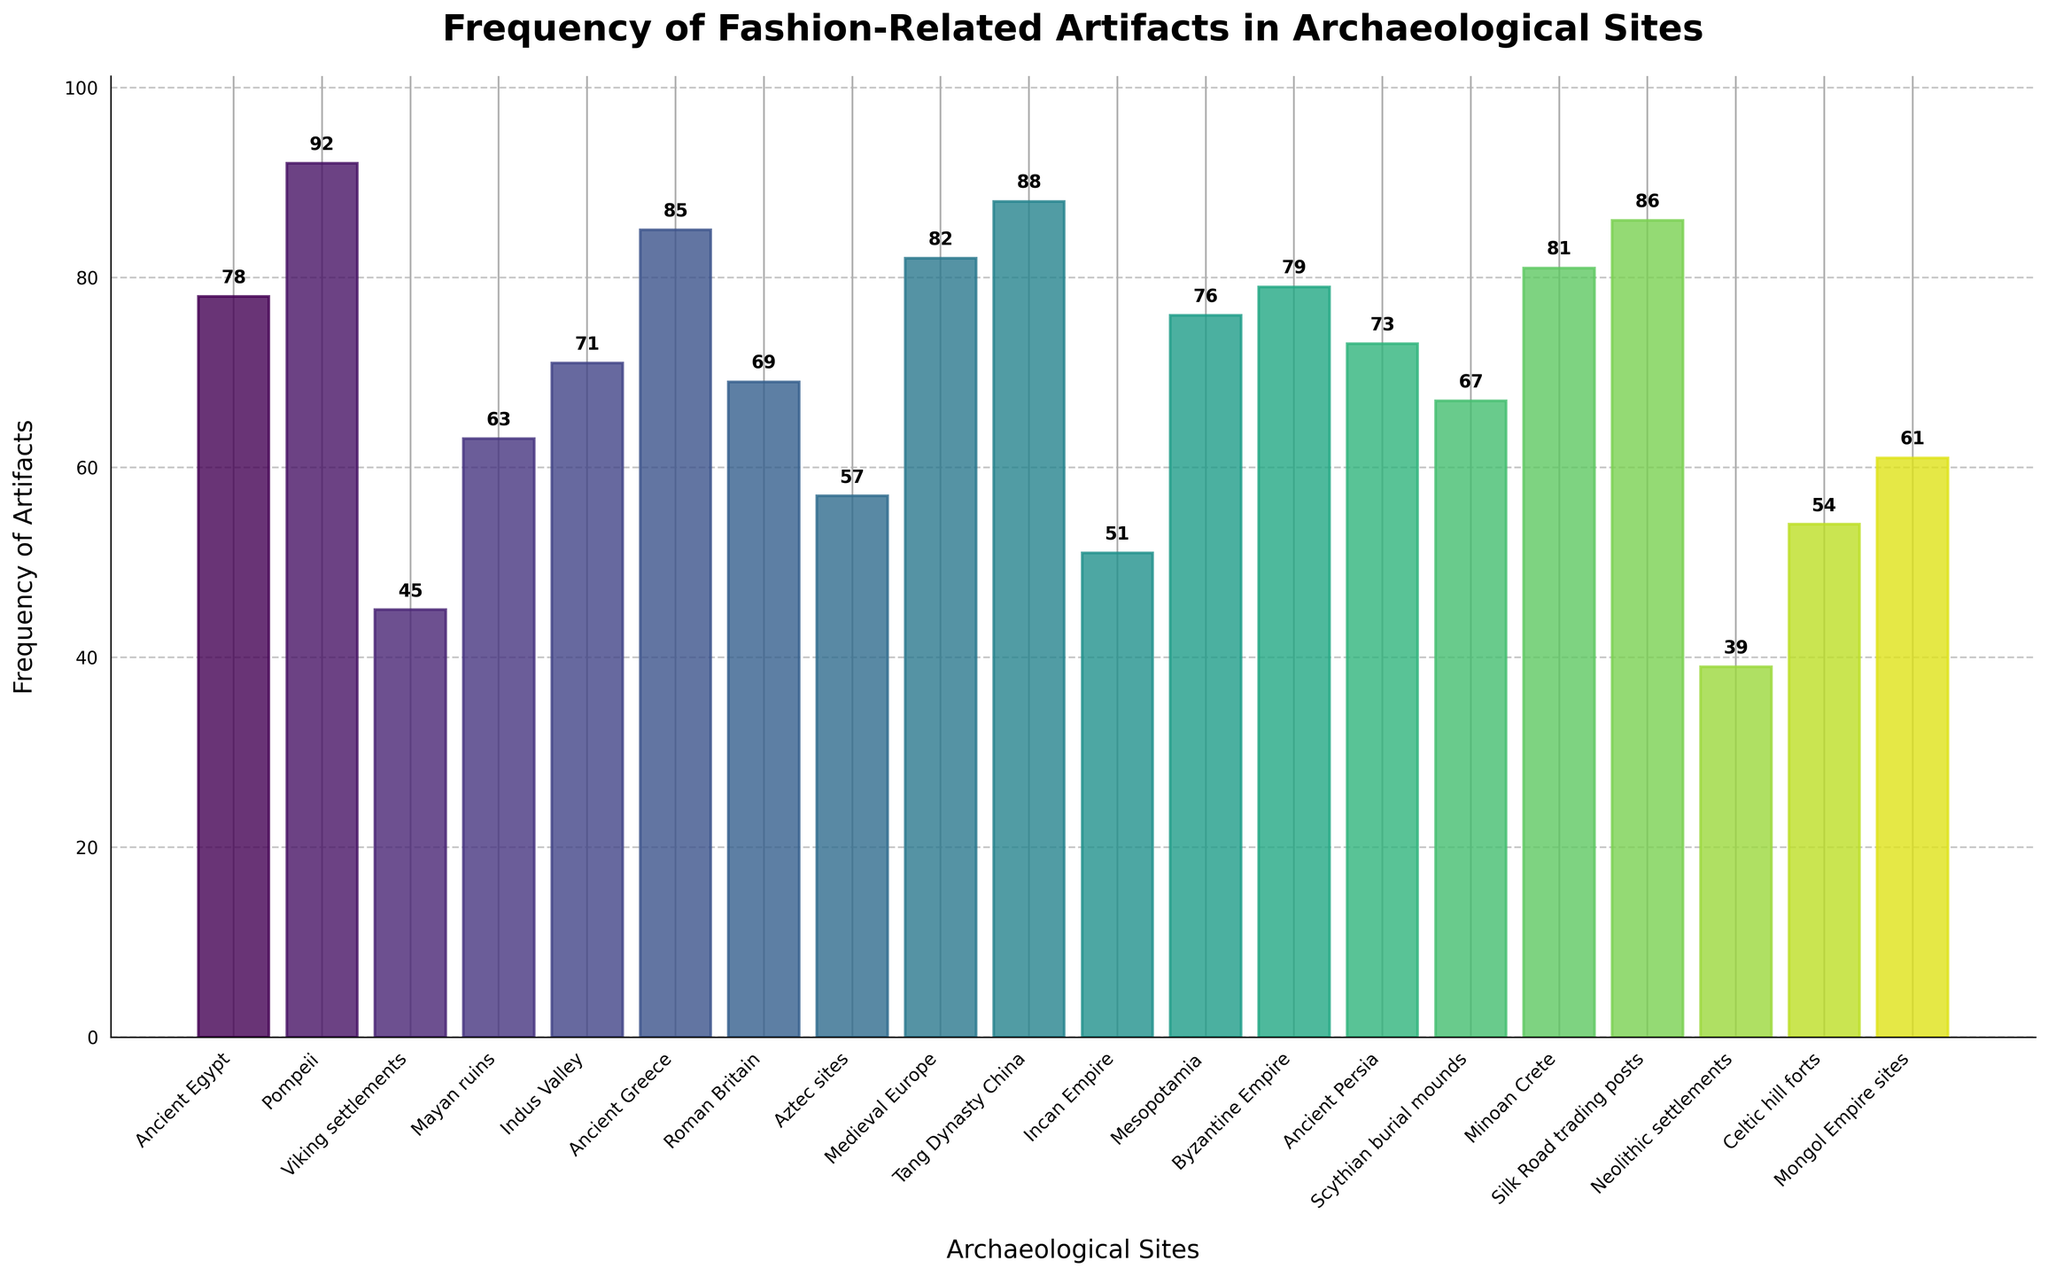Which archaeological site has the highest frequency of fashion-related artifacts? Look at the bar with the greatest height. Pompeii is the site with the highest frequency of 92 artifacts.
Answer: Pompeii Which two archaeological sites have the closest frequency of fashion-related artifacts? Identify artifacts that are numerically closest. Sites "Byzantine Empire" and "Ancient Persia" have frequencies of 79 and 73, respectively.
Answer: Byzantine Empire and Ancient Persia What is the total frequency of fashion-related artifacts found in Ancient Greece, Roman Britain, and the Incan Empire sites? Sum the frequencies for Ancient Greece (85), Roman Britain (69), and Incan Empire (51). The total is 85 + 69 + 51 = 205.
Answer: 205 Which archaeological site has the lowest frequency of fashion-related artifacts? Look at the bar with the shortest height. Neolithic settlements have the lowest frequency of 39 artifacts.
Answer: Neolithic settlements What is the average frequency of fashion-related artifacts across all sites? Sum all frequencies and then divide by the number of sites (20). (78 + 92 + 45 + 63 + 71 + 85 + 69 + 57 + 82 + 88 + 51 + 76 + 79 + 73 + 67 + 81 + 86 + 39 + 54 + 61) = 1357. 1357 / 20 = 67.85
Answer: 67.85 Which site has a frequency of fashion-related artifacts closest to 60? Look for a frequency close to 60. The site with 61 artifacts is the Mongol Empire sites, which is closest to 60.
Answer: Mongol Empire sites Which site has a frequency of fashion-related artifacts that is greater than both Ancient Egypt and the Indus Valley but less than Ancient Greece? Identify artifacts within the range: 78 (Ancient Egypt) < site < 85 (Ancient Greece). The Byzantine Empire (79) fits.
Answer: Byzantine Empire What is the difference in the frequency of artifacts between Mayan ruins and Viking settlements? Subtract the frequency of Viking settlements (45) from Mayan ruins (63). 63 - 45 = 18.
Answer: 18 Identify two sites where the total frequency of artifacts is over 160 when combined. Look for pairs: combining Ancient Greece (85) and Medieval Europe (82) totals 167, over 160.
Answer: Ancient Greece and Medieval Europe How many sites have a frequency of fashion-related artifacts that is greater than 80? Count the bars with frequencies greater than 80. Ancient Greece (85), Medieval Europe (82), Tang Dynasty China (88), Byzantine Empire (79), Silk Road trading posts (86), Minoan Crete (81), and Pompeii (92) appear.
Answer: 7 